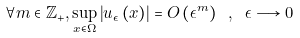Convert formula to latex. <formula><loc_0><loc_0><loc_500><loc_500>\forall m \in \mathbb { Z } _ { + } , \underset { x \in \Omega } { \sup } \left | u _ { \epsilon } \left ( x \right ) \right | = O \left ( \epsilon ^ { m } \right ) \text { } , \text { } \epsilon \longrightarrow 0</formula> 